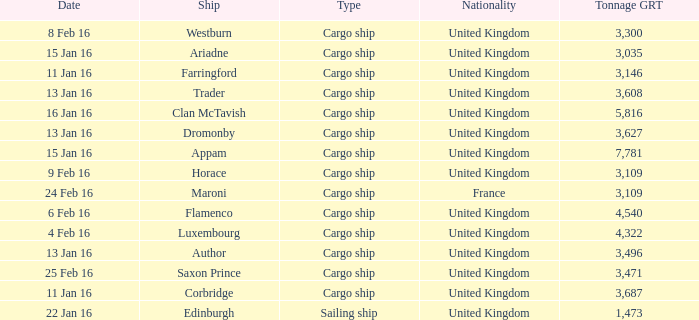What is the most tonnage grt of any ship sunk or captured on 16 jan 16? 5816.0. 